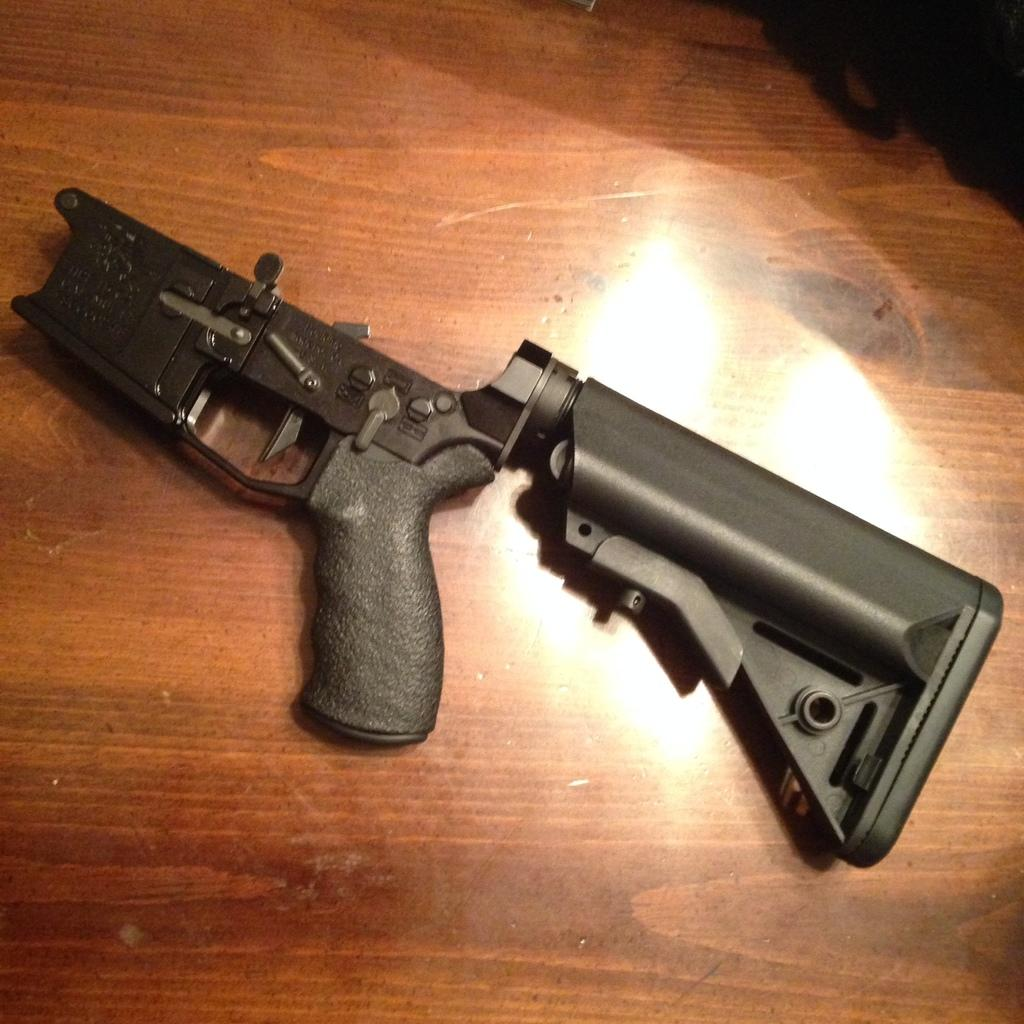What object is the main focus of the image? There is a gun in the image. What is the color of the gun? The gun is black in color. Where is the gun located in the image? The gun is placed on a table. What type of celery is being used to stir the gun in the image? There is no celery present in the image, and the gun is not being stirred. 